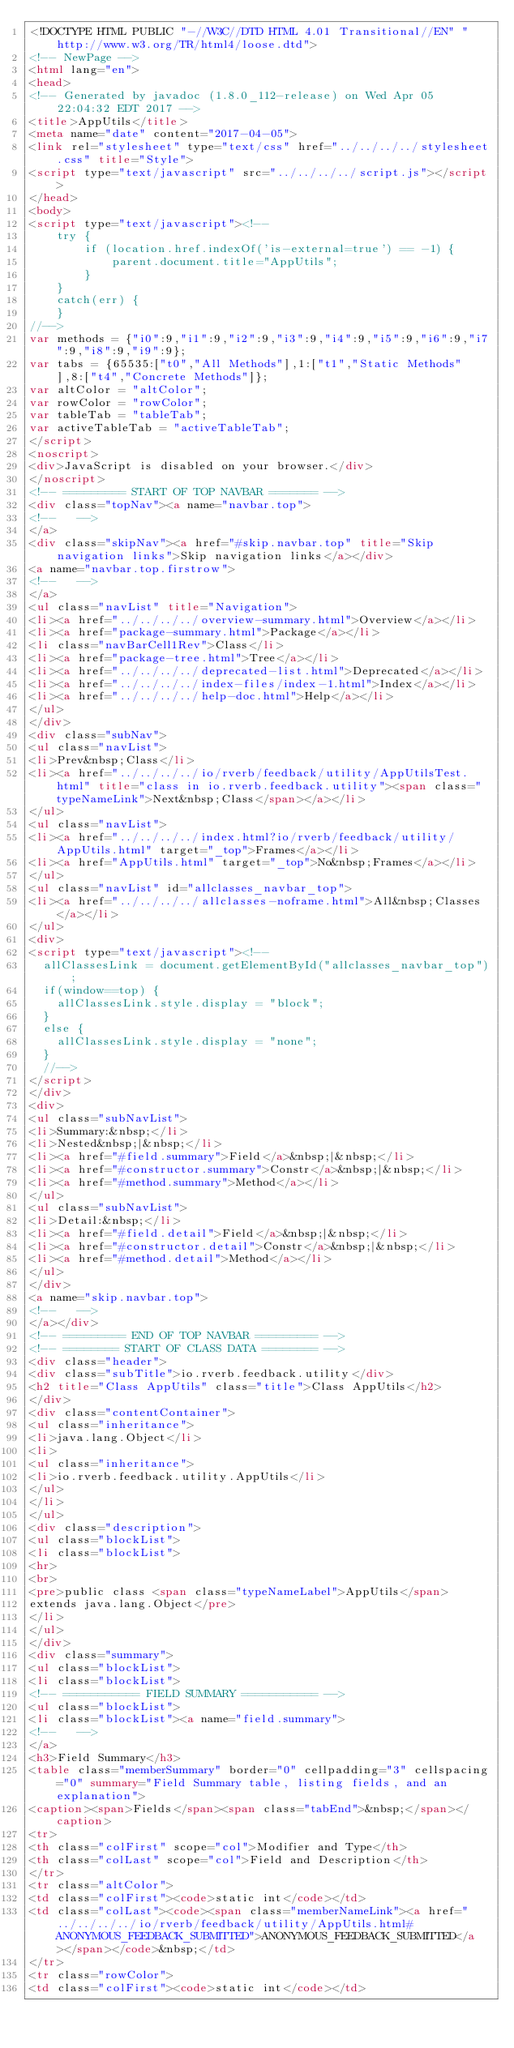Convert code to text. <code><loc_0><loc_0><loc_500><loc_500><_HTML_><!DOCTYPE HTML PUBLIC "-//W3C//DTD HTML 4.01 Transitional//EN" "http://www.w3.org/TR/html4/loose.dtd">
<!-- NewPage -->
<html lang="en">
<head>
<!-- Generated by javadoc (1.8.0_112-release) on Wed Apr 05 22:04:32 EDT 2017 -->
<title>AppUtils</title>
<meta name="date" content="2017-04-05">
<link rel="stylesheet" type="text/css" href="../../../../stylesheet.css" title="Style">
<script type="text/javascript" src="../../../../script.js"></script>
</head>
<body>
<script type="text/javascript"><!--
    try {
        if (location.href.indexOf('is-external=true') == -1) {
            parent.document.title="AppUtils";
        }
    }
    catch(err) {
    }
//-->
var methods = {"i0":9,"i1":9,"i2":9,"i3":9,"i4":9,"i5":9,"i6":9,"i7":9,"i8":9,"i9":9};
var tabs = {65535:["t0","All Methods"],1:["t1","Static Methods"],8:["t4","Concrete Methods"]};
var altColor = "altColor";
var rowColor = "rowColor";
var tableTab = "tableTab";
var activeTableTab = "activeTableTab";
</script>
<noscript>
<div>JavaScript is disabled on your browser.</div>
</noscript>
<!-- ========= START OF TOP NAVBAR ======= -->
<div class="topNav"><a name="navbar.top">
<!--   -->
</a>
<div class="skipNav"><a href="#skip.navbar.top" title="Skip navigation links">Skip navigation links</a></div>
<a name="navbar.top.firstrow">
<!--   -->
</a>
<ul class="navList" title="Navigation">
<li><a href="../../../../overview-summary.html">Overview</a></li>
<li><a href="package-summary.html">Package</a></li>
<li class="navBarCell1Rev">Class</li>
<li><a href="package-tree.html">Tree</a></li>
<li><a href="../../../../deprecated-list.html">Deprecated</a></li>
<li><a href="../../../../index-files/index-1.html">Index</a></li>
<li><a href="../../../../help-doc.html">Help</a></li>
</ul>
</div>
<div class="subNav">
<ul class="navList">
<li>Prev&nbsp;Class</li>
<li><a href="../../../../io/rverb/feedback/utility/AppUtilsTest.html" title="class in io.rverb.feedback.utility"><span class="typeNameLink">Next&nbsp;Class</span></a></li>
</ul>
<ul class="navList">
<li><a href="../../../../index.html?io/rverb/feedback/utility/AppUtils.html" target="_top">Frames</a></li>
<li><a href="AppUtils.html" target="_top">No&nbsp;Frames</a></li>
</ul>
<ul class="navList" id="allclasses_navbar_top">
<li><a href="../../../../allclasses-noframe.html">All&nbsp;Classes</a></li>
</ul>
<div>
<script type="text/javascript"><!--
  allClassesLink = document.getElementById("allclasses_navbar_top");
  if(window==top) {
    allClassesLink.style.display = "block";
  }
  else {
    allClassesLink.style.display = "none";
  }
  //-->
</script>
</div>
<div>
<ul class="subNavList">
<li>Summary:&nbsp;</li>
<li>Nested&nbsp;|&nbsp;</li>
<li><a href="#field.summary">Field</a>&nbsp;|&nbsp;</li>
<li><a href="#constructor.summary">Constr</a>&nbsp;|&nbsp;</li>
<li><a href="#method.summary">Method</a></li>
</ul>
<ul class="subNavList">
<li>Detail:&nbsp;</li>
<li><a href="#field.detail">Field</a>&nbsp;|&nbsp;</li>
<li><a href="#constructor.detail">Constr</a>&nbsp;|&nbsp;</li>
<li><a href="#method.detail">Method</a></li>
</ul>
</div>
<a name="skip.navbar.top">
<!--   -->
</a></div>
<!-- ========= END OF TOP NAVBAR ========= -->
<!-- ======== START OF CLASS DATA ======== -->
<div class="header">
<div class="subTitle">io.rverb.feedback.utility</div>
<h2 title="Class AppUtils" class="title">Class AppUtils</h2>
</div>
<div class="contentContainer">
<ul class="inheritance">
<li>java.lang.Object</li>
<li>
<ul class="inheritance">
<li>io.rverb.feedback.utility.AppUtils</li>
</ul>
</li>
</ul>
<div class="description">
<ul class="blockList">
<li class="blockList">
<hr>
<br>
<pre>public class <span class="typeNameLabel">AppUtils</span>
extends java.lang.Object</pre>
</li>
</ul>
</div>
<div class="summary">
<ul class="blockList">
<li class="blockList">
<!-- =========== FIELD SUMMARY =========== -->
<ul class="blockList">
<li class="blockList"><a name="field.summary">
<!--   -->
</a>
<h3>Field Summary</h3>
<table class="memberSummary" border="0" cellpadding="3" cellspacing="0" summary="Field Summary table, listing fields, and an explanation">
<caption><span>Fields</span><span class="tabEnd">&nbsp;</span></caption>
<tr>
<th class="colFirst" scope="col">Modifier and Type</th>
<th class="colLast" scope="col">Field and Description</th>
</tr>
<tr class="altColor">
<td class="colFirst"><code>static int</code></td>
<td class="colLast"><code><span class="memberNameLink"><a href="../../../../io/rverb/feedback/utility/AppUtils.html#ANONYMOUS_FEEDBACK_SUBMITTED">ANONYMOUS_FEEDBACK_SUBMITTED</a></span></code>&nbsp;</td>
</tr>
<tr class="rowColor">
<td class="colFirst"><code>static int</code></td></code> 